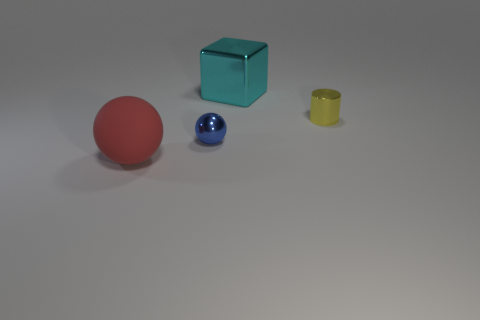What number of other things are there of the same shape as the red object? Including the red object, there is one other item that shares its spherical shape, which appears to be a smaller blue sphere. 